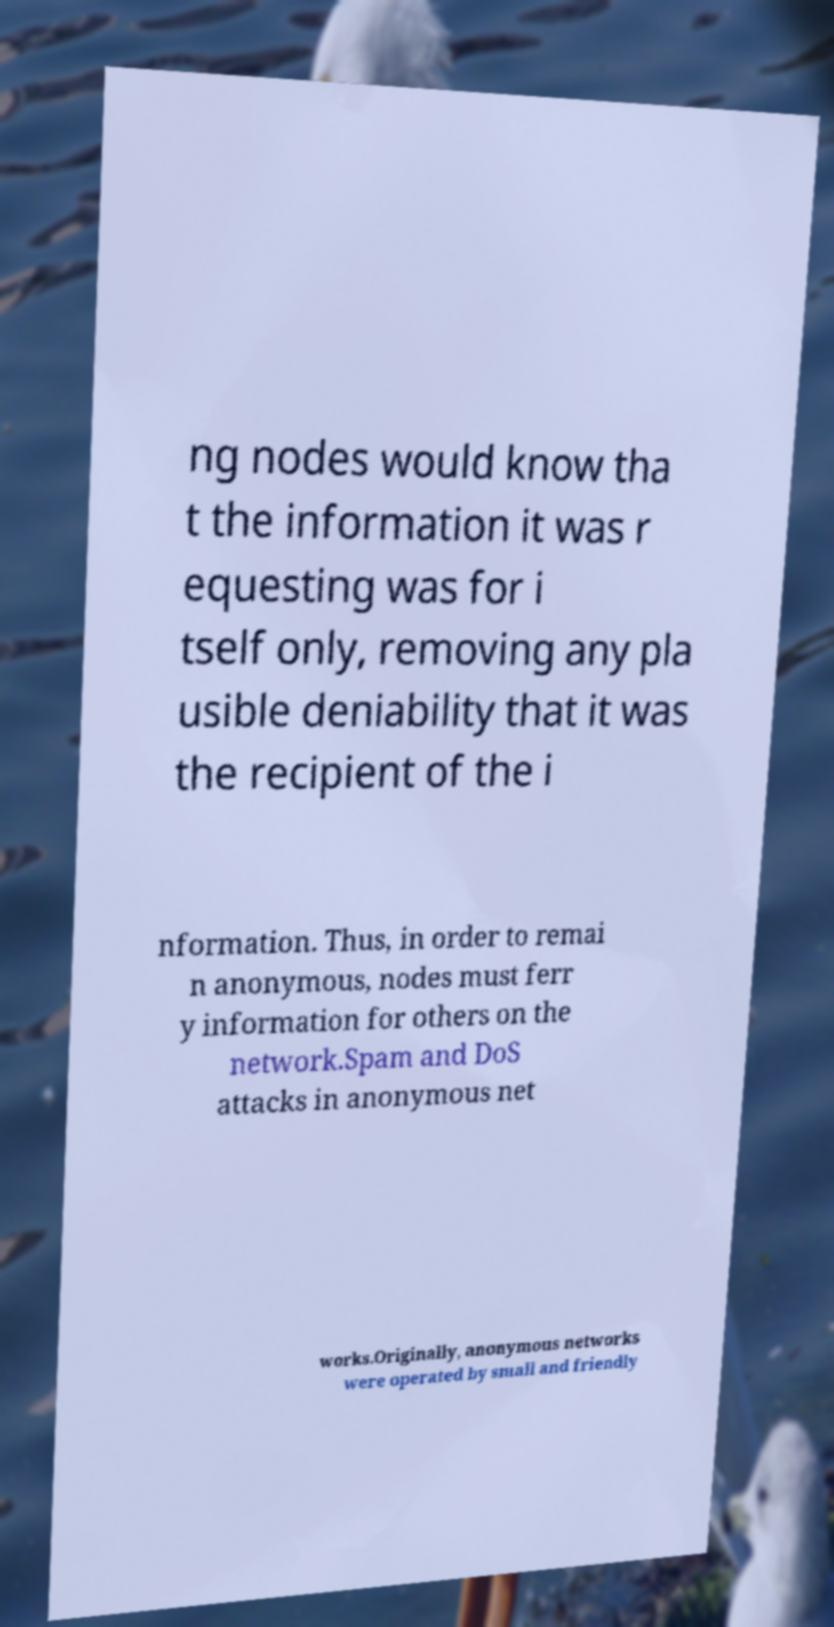For documentation purposes, I need the text within this image transcribed. Could you provide that? ng nodes would know tha t the information it was r equesting was for i tself only, removing any pla usible deniability that it was the recipient of the i nformation. Thus, in order to remai n anonymous, nodes must ferr y information for others on the network.Spam and DoS attacks in anonymous net works.Originally, anonymous networks were operated by small and friendly 